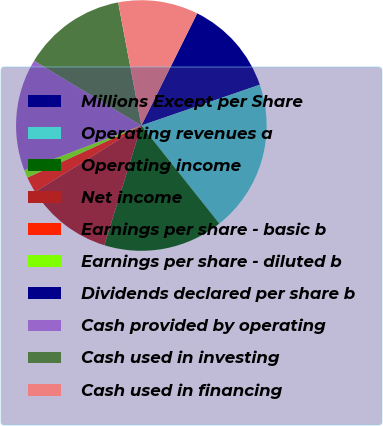<chart> <loc_0><loc_0><loc_500><loc_500><pie_chart><fcel>Millions Except per Share<fcel>Operating revenues a<fcel>Operating income<fcel>Net income<fcel>Earnings per share - basic b<fcel>Earnings per share - diluted b<fcel>Dividends declared per share b<fcel>Cash provided by operating<fcel>Cash used in investing<fcel>Cash used in financing<nl><fcel>12.37%<fcel>19.59%<fcel>15.46%<fcel>11.34%<fcel>2.06%<fcel>1.03%<fcel>0.0%<fcel>14.43%<fcel>13.4%<fcel>10.31%<nl></chart> 